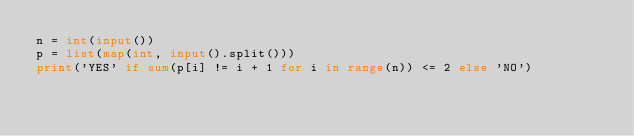<code> <loc_0><loc_0><loc_500><loc_500><_Python_>n = int(input())
p = list(map(int, input().split()))
print('YES' if sum(p[i] != i + 1 for i in range(n)) <= 2 else 'NO')</code> 